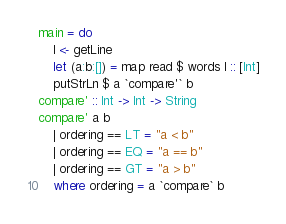Convert code to text. <code><loc_0><loc_0><loc_500><loc_500><_Haskell_>main = do
    l <- getLine
    let (a:b:[]) = map read $ words l :: [Int]
    putStrLn $ a `compare'` b
compare' :: Int -> Int -> String
compare' a b
    | ordering == LT = "a < b"
    | ordering == EQ = "a == b"
    | ordering == GT = "a > b"
    where ordering = a `compare` b</code> 